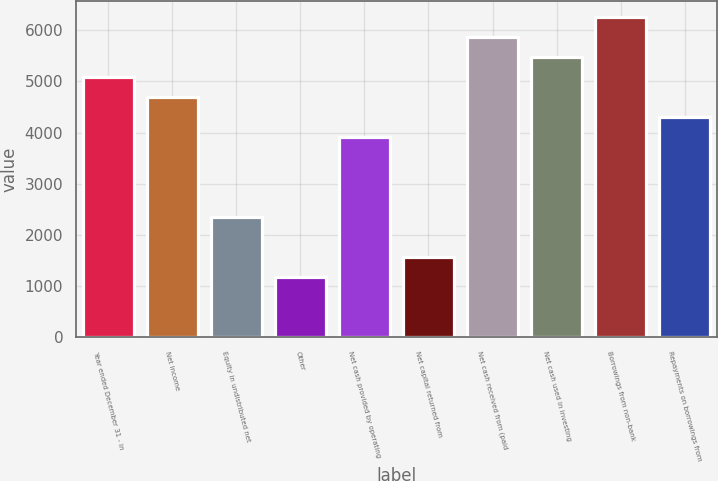Convert chart. <chart><loc_0><loc_0><loc_500><loc_500><bar_chart><fcel>Year ended December 31 - in<fcel>Net income<fcel>Equity in undistributed net<fcel>Other<fcel>Net cash provided by operating<fcel>Net capital returned from<fcel>Net cash received from (paid<fcel>Net cash used in investing<fcel>Borrowings from non-bank<fcel>Repayments on borrowings from<nl><fcel>5082.4<fcel>4691.6<fcel>2346.8<fcel>1174.4<fcel>3910<fcel>1565.2<fcel>5864<fcel>5473.2<fcel>6254.8<fcel>4300.8<nl></chart> 